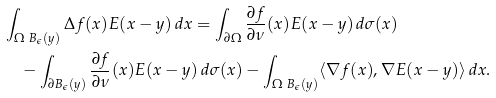Convert formula to latex. <formula><loc_0><loc_0><loc_500><loc_500>& \int _ { \Omega \ B _ { \epsilon } ( y ) } \Delta f ( x ) E ( x - y ) \, d x = \int _ { \partial \Omega } \frac { \partial f } { \partial \nu } ( x ) E ( x - y ) \, d \sigma ( x ) \\ & \quad - \int _ { \partial B _ { \epsilon } ( y ) } \frac { \partial f } { \partial \nu } ( x ) E ( x - y ) \, d \sigma ( x ) - \int _ { \Omega \ B _ { \epsilon } ( y ) } \langle \nabla f ( x ) , \nabla E ( x - y ) \rangle \, d x .</formula> 